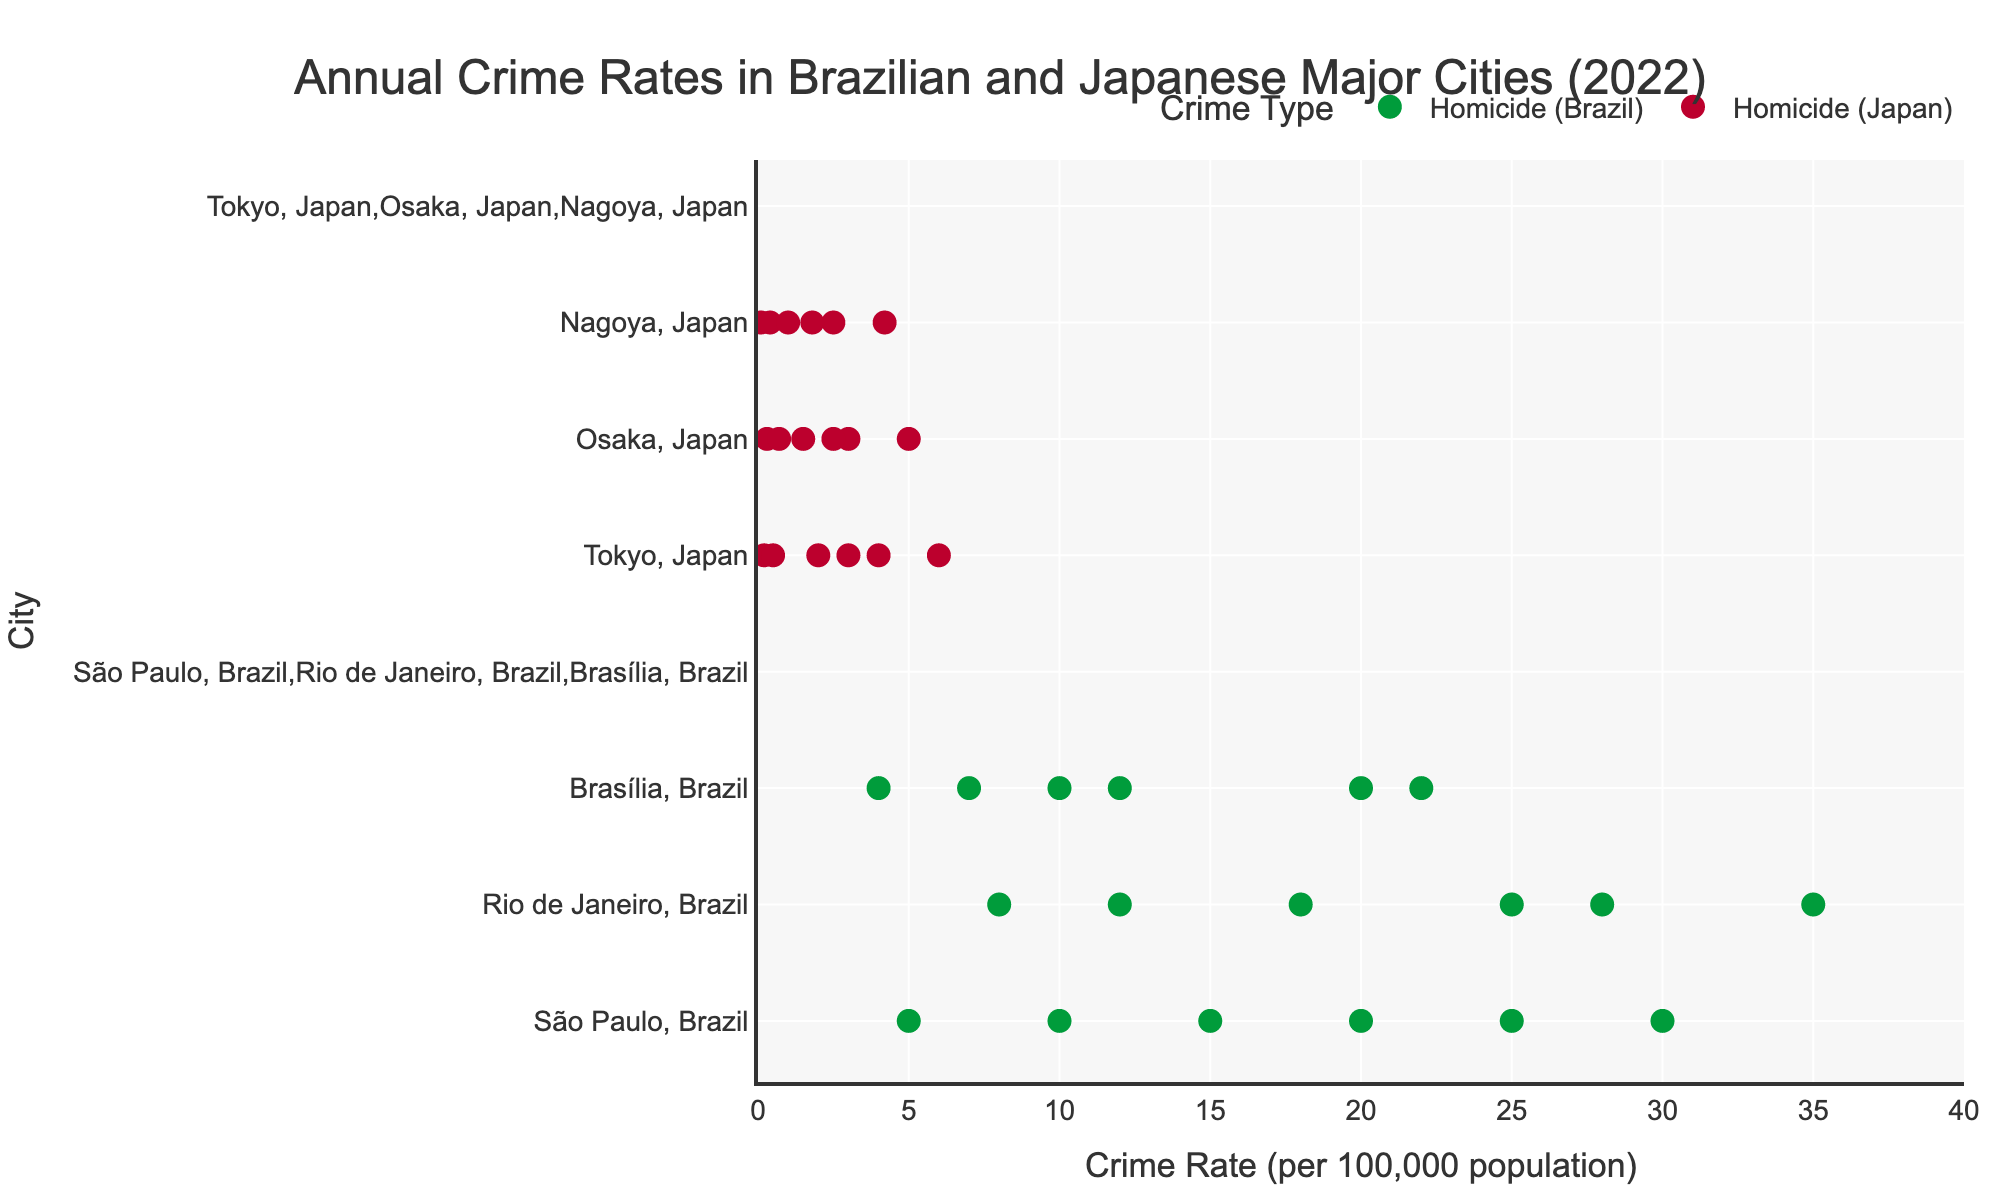What's the title of the figure? The title is usually found at the top of the figure. In this case, it reads, "Annual Crime Rates in Brazilian and Japanese Major Cities (2022)."
Answer: Annual Crime Rates in Brazilian and Japanese Major Cities (2022) What are the two countries compared in the figure? The countries are distinguished by their dot colors (green for Brazil, red for Japan) and by the city names labeled next to the dots.
Answer: Brazil and Japan Which city in Brazil has the highest maximum robbery rate? By looking at the maximum points for robbery rates, Rio de Janeiro has the highest maximum robbery rate with a value of 35.0.
Answer: Rio de Janeiro In which city and country is the minimum homicide rate the lowest, and what is that rate? The minimum homicide rates are marked by the leftmost points. Nagoya, Japan, has the lowest minimum homicide rate at 0.1.
Answer: Nagoya, Japan, 0.1 What's the range of burglary rates in São Paulo, Brazil? The range is the difference between the maximum and minimum rates. São Paulo has a minimum burglary rate of 15.0 and a maximum of 25.0, so the range is 25.0 - 15.0 = 10.0.
Answer: 10.0 How does the maximum homicide rate in Rio de Janeiro compare to that of São Paulo? By comparing the maximum rates, Rio de Janeiro's maximum homicide rate is 12.0 while São Paulo's is 10.0. Thus, Rio de Janeiro's is higher.
Answer: Rio de Janeiro's is higher Which city has the tightest range of robbery rates in Japan? The tightest range would be the smallest difference between maximum and minimum rates. Comparing Tokyo (2.0 to 4.0), Osaka (1.5 to 3.0), and Nagoya (1.0 to 2.5), Nagoya has the smallest range, which is 2.5 - 1.0 = 1.5.
Answer: Nagoya What is the average burglary rate range across all Japanese cities? First, calculate the range for each city: Tokyo (6.0 - 3.0 = 3.0), Osaka (5.0 - 2.5 = 2.5), Nagoya (4.2 - 1.8 = 2.4). Then, average these ranges: (3.0 + 2.5 + 2.4) / 3 = 2.63.
Answer: 2.63 Which country appears to have lower homicide rates overall? Comparing the two countries’ cities, Japan’s cities (Tokyo, Osaka, Nagoya) have lower homicide rates across the board compared to Brazilian cities.
Answer: Japan 